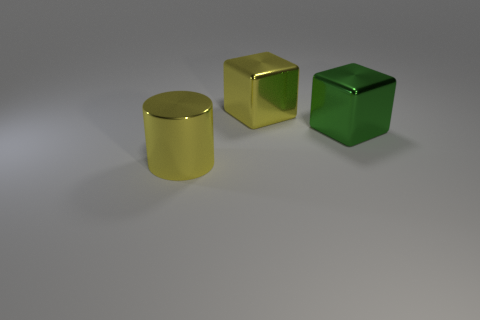What can you infer about the shapes of the objects in terms of geometry? The image displays three distinct geometric shapes which are a cylinder, a cube, and a rectangular prism. Each has well-defined edges and faces that are characteristic of their respective geometries. Can you guess the relative sizes of these objects? While the exact dimensions are not provided, one can infer that the green block is the smallest in terms of height, the yellow cylinder and the gold cube appear to be of intermediate heights, and the large yellow cube is the tallest and the most voluminous of the objects presented. 